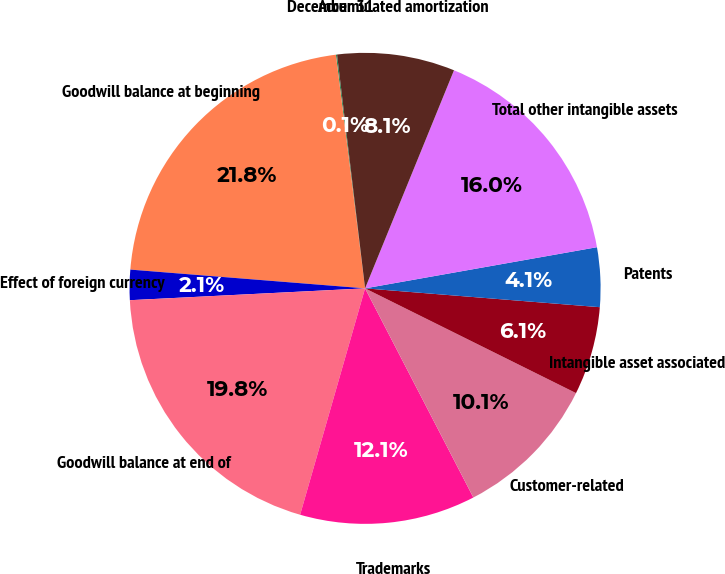Convert chart. <chart><loc_0><loc_0><loc_500><loc_500><pie_chart><fcel>December 31<fcel>Goodwill balance at beginning<fcel>Effect of foreign currency<fcel>Goodwill balance at end of<fcel>Trademarks<fcel>Customer-related<fcel>Intangible asset associated<fcel>Patents<fcel>Total other intangible assets<fcel>Accumulated amortization<nl><fcel>0.08%<fcel>21.75%<fcel>2.07%<fcel>19.75%<fcel>12.05%<fcel>10.06%<fcel>6.06%<fcel>4.07%<fcel>16.04%<fcel>8.06%<nl></chart> 